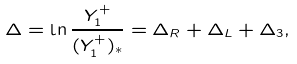<formula> <loc_0><loc_0><loc_500><loc_500>\Delta = \ln \frac { Y _ { 1 } ^ { + } } { ( Y ^ { + } _ { 1 } ) _ { * } } = \Delta _ { R } + \Delta _ { L } + \Delta _ { 3 } ,</formula> 